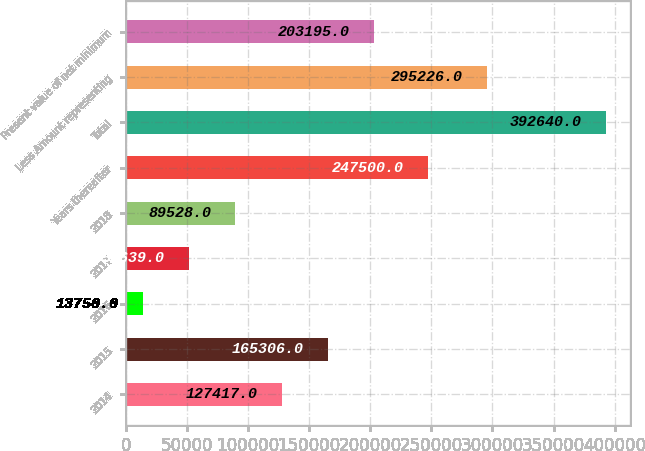<chart> <loc_0><loc_0><loc_500><loc_500><bar_chart><fcel>2014<fcel>2015<fcel>2016<fcel>2017<fcel>2018<fcel>Years thereafter<fcel>Total<fcel>Less Amount representing<fcel>Present value of net minimum<nl><fcel>127417<fcel>165306<fcel>13750<fcel>51639<fcel>89528<fcel>247500<fcel>392640<fcel>295226<fcel>203195<nl></chart> 